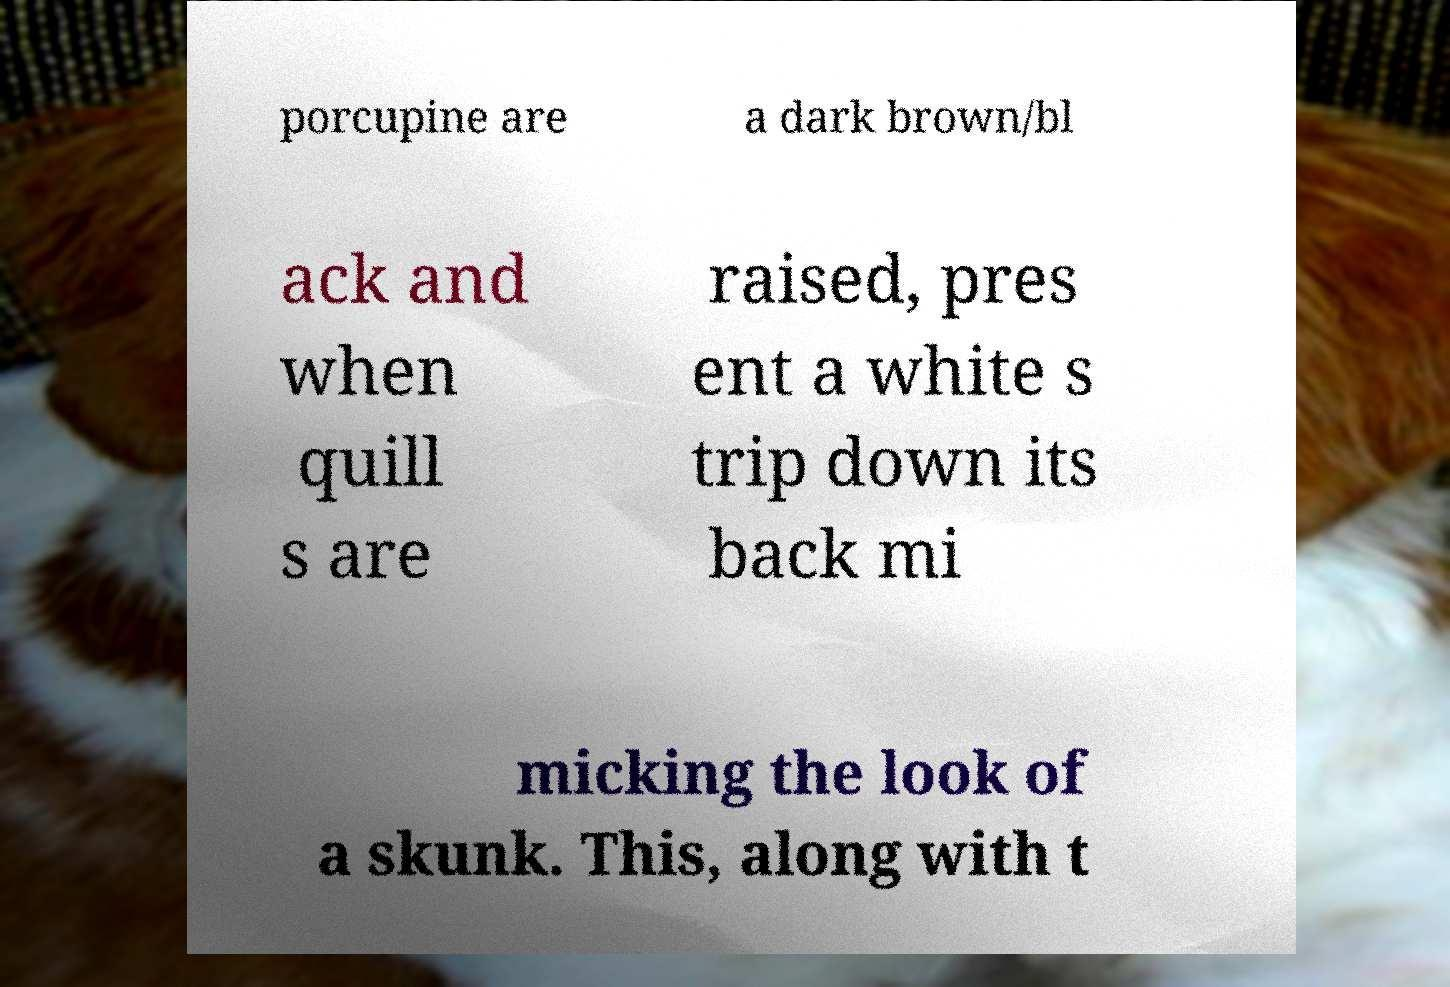Can you accurately transcribe the text from the provided image for me? porcupine are a dark brown/bl ack and when quill s are raised, pres ent a white s trip down its back mi micking the look of a skunk. This, along with t 